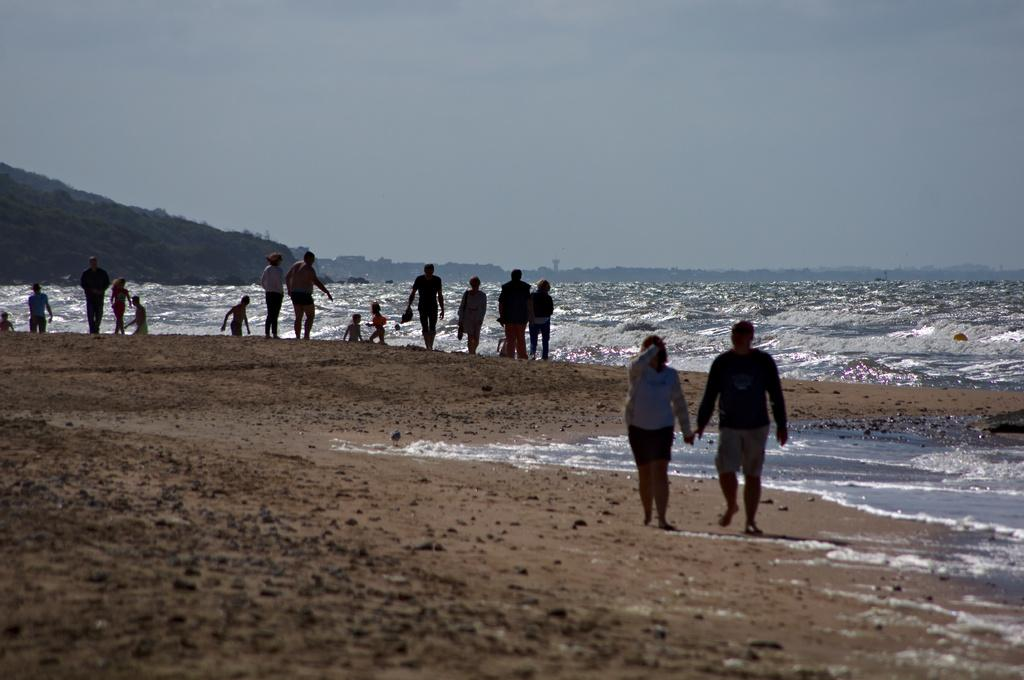What is the main subject of the image? The main subject of the image is a group of people standing. What can be seen in the background of the image? There is water visible in the image, and the sky is visible in the background. What type of terrain is present in the image? There is a hill in the image. What type of education is being provided by the maid in the image? There is no maid or education present in the image. 